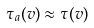<formula> <loc_0><loc_0><loc_500><loc_500>\tau _ { a } ( v ) \approx \tau ( v )</formula> 